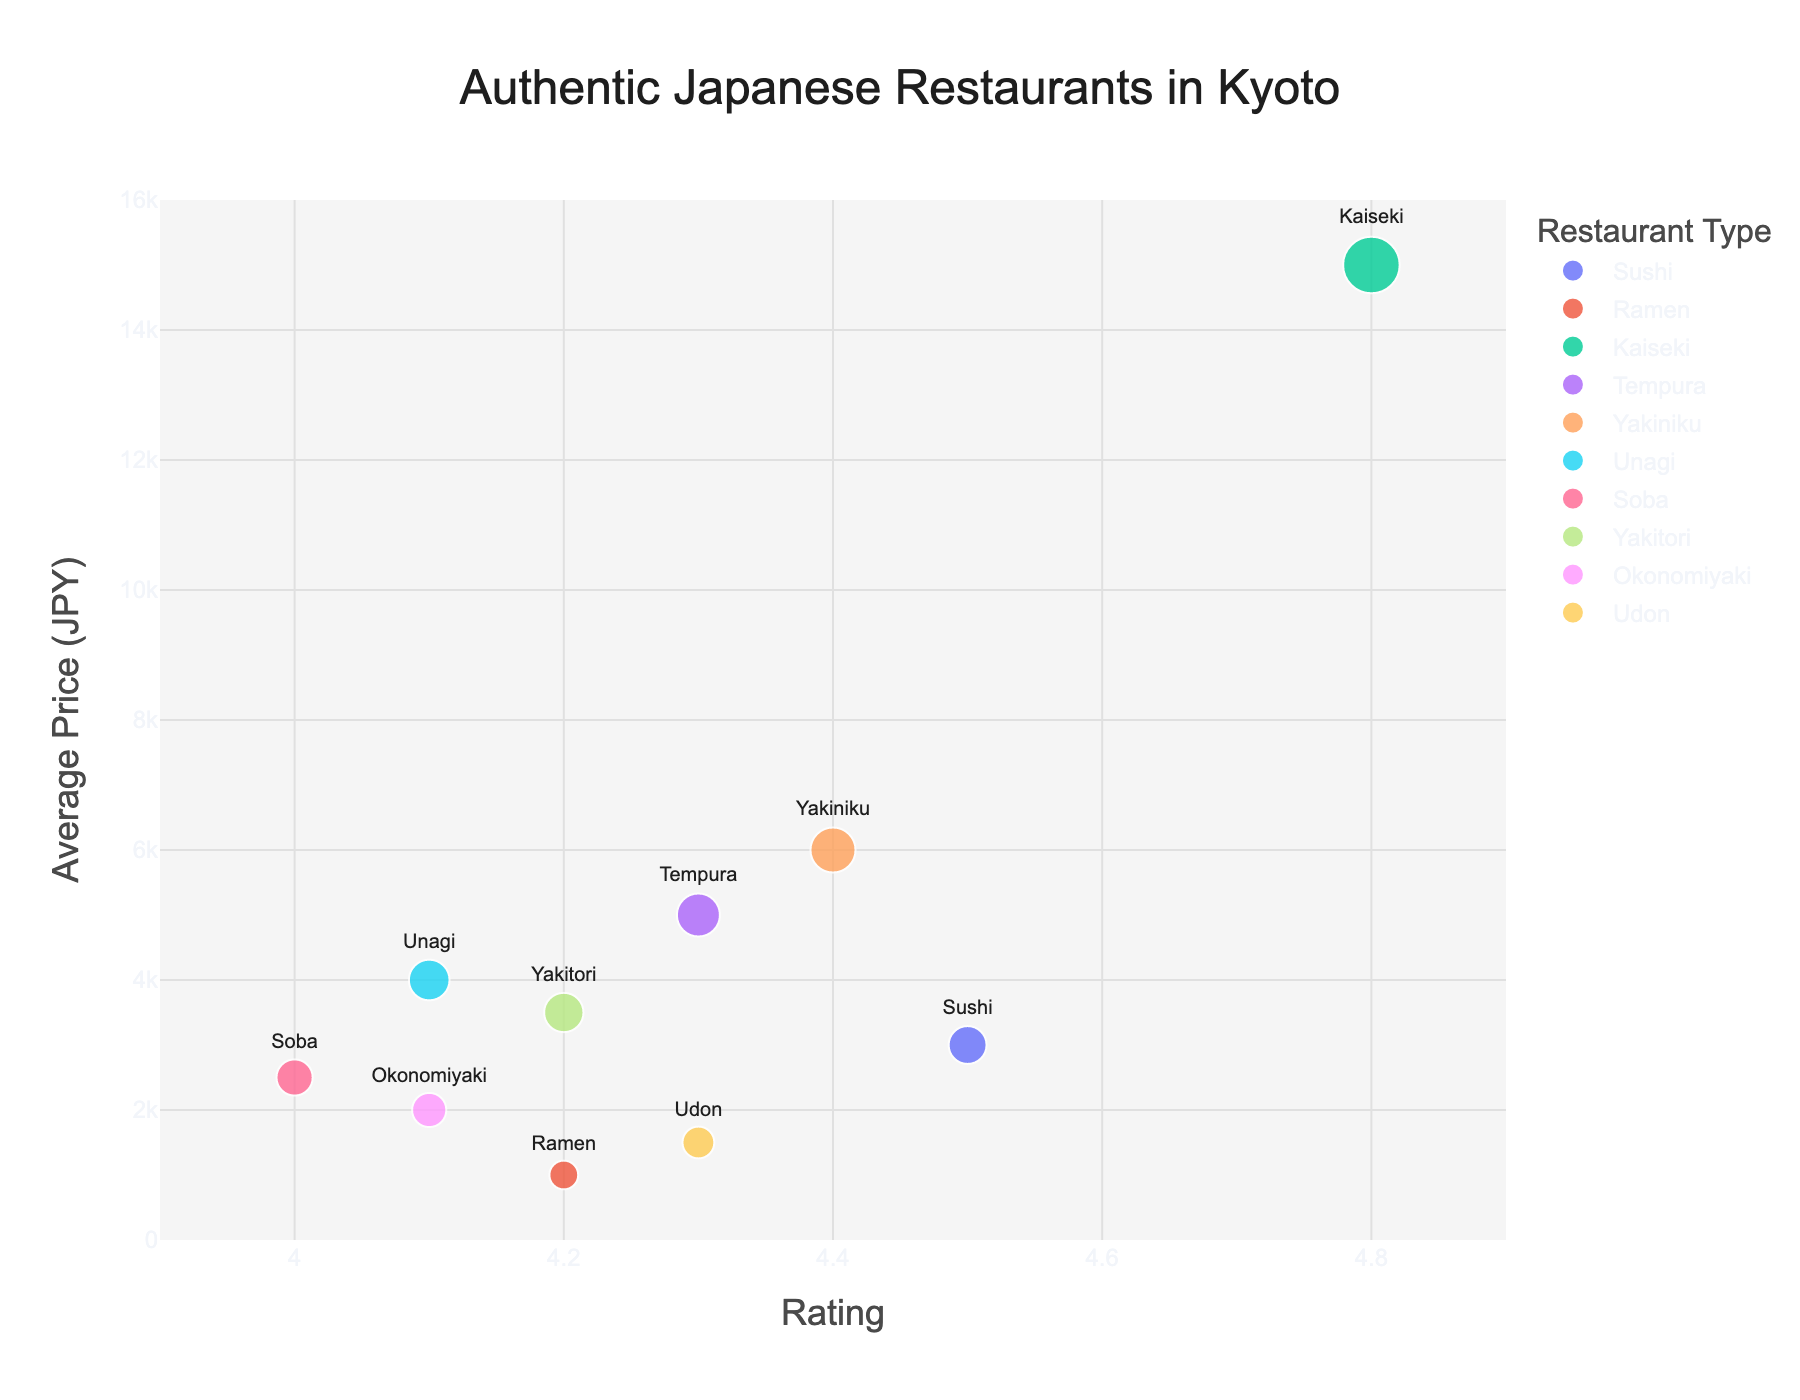What is the title of the chart? The title of the chart is displayed at the top and it's written in large text. It helps viewers understand what the chart is about.
Answer: Authentic Japanese Restaurants in Kyoto How many types of restaurants are represented in the chart? The legend shows the various types of restaurants, each represented by a different color. By counting the number of distinct colors/types, we can determine the number of restaurant types.
Answer: 10 What is the range of the average prices in the chart? The y-axis represents the average prices and is labeled accordingly. By looking at the lowest and highest values on this axis, we can determine the range.
Answer: 1,000 JPY to 15,000 JPY Which restaurant type has the highest rating? The x-axis represents the rating, and the restaurant type with the highest x-value will have the highest rating. By inspecting this value, we can identify the restaurant type.
Answer: Kaiseki How does the average price of Sushi compare to that of Tempura? The y-axis represents the average prices. By locating the bubble for Sushi and Tempura and comparing their y-values, we can determine how their average prices compare.
Answer: Sushi is cheaper than Tempura Which restaurant has the largest bubble on the chart? Bubble size is determined by the average price. By looking for the largest bubble and checking the hover information or legend, we can find the restaurant with the largest bubble.
Answer: Gion Sasaki (Kaiseki) What is the average rating of Soba and Udon restaurants? Find the x-values for Soba and Udon, which represent their ratings. Sum these ratings and divide by the number of restaurant types (2) to find the average.
Answer: (4.0 + 4.3) / 2 = 4.15 Based on the chart, which restaurant type offers the highest average price? The y-axis displays average prices, and the highest value on this axis will represent the type with the highest average price.
Answer: Kaiseki How many restaurants have an average price over 5000 JPY? By identifying the bubbles with y-values greater than 5000 JPY, we can count how many restaurants fit this criterion.
Answer: 2 What is the relationship between average price and rating for Sushi compared to Yakiniku? To compare Sushi and Yakiniku, check the x-values (rating) and y-values (average price) for both and describe their positions relative to each other.
Answer: Sushi: lower price, higher rating; Yakiniku: higher price, slightly lower rating 